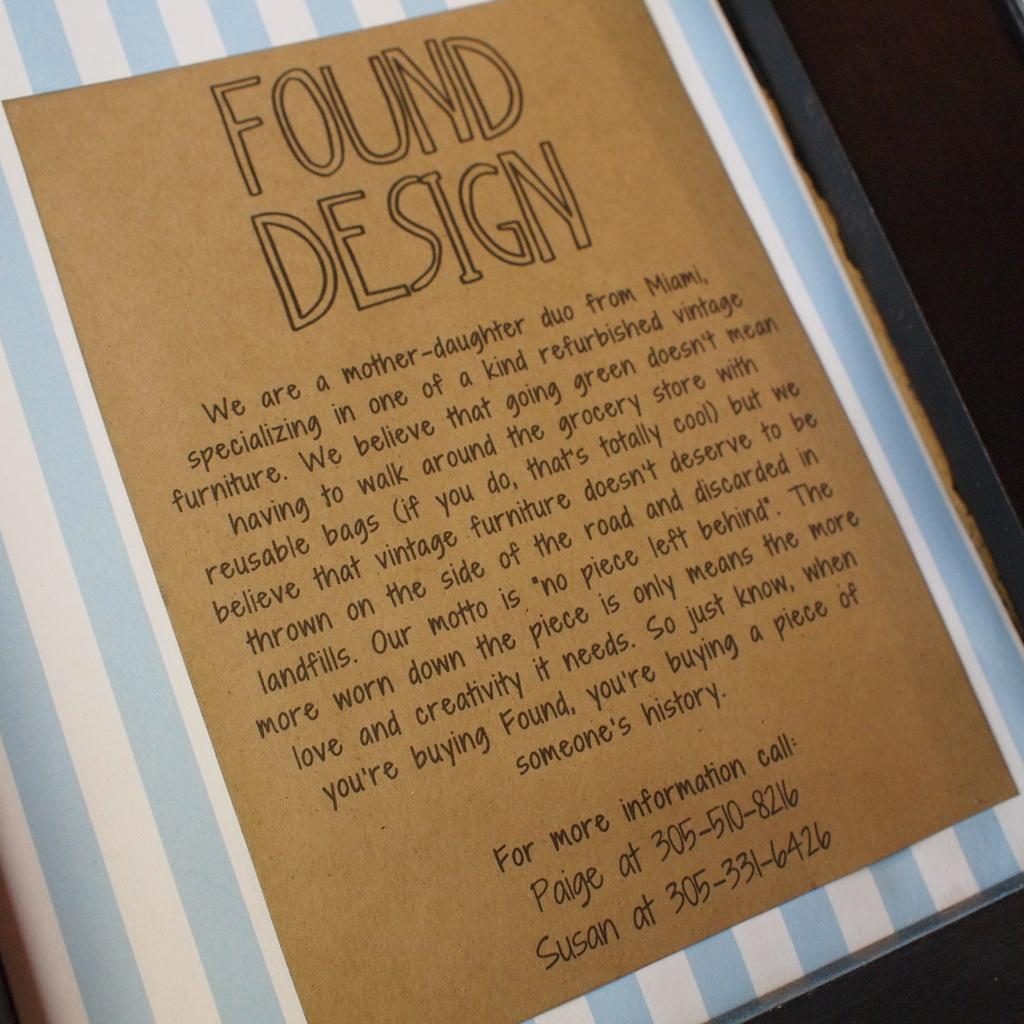<image>
Give a short and clear explanation of the subsequent image. For more information about found design people can call Paige or Susan. 